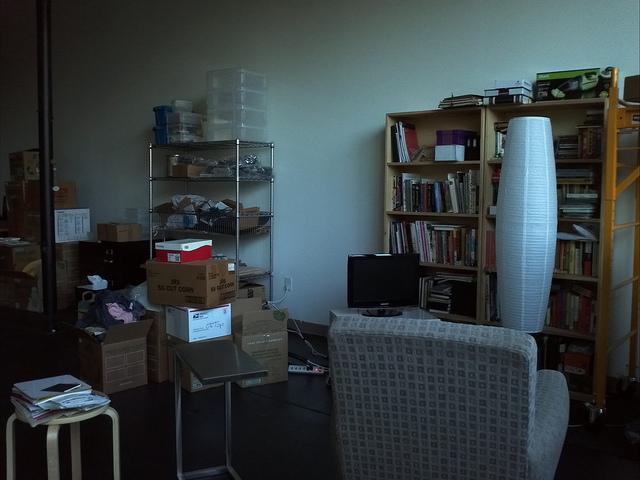Is the lamp on or off?
Keep it brief. Off. Is the monitor on?
Quick response, please. No. What words are displayed?
Answer briefly. None. How many bookcases are in the room?
Keep it brief. 2. 